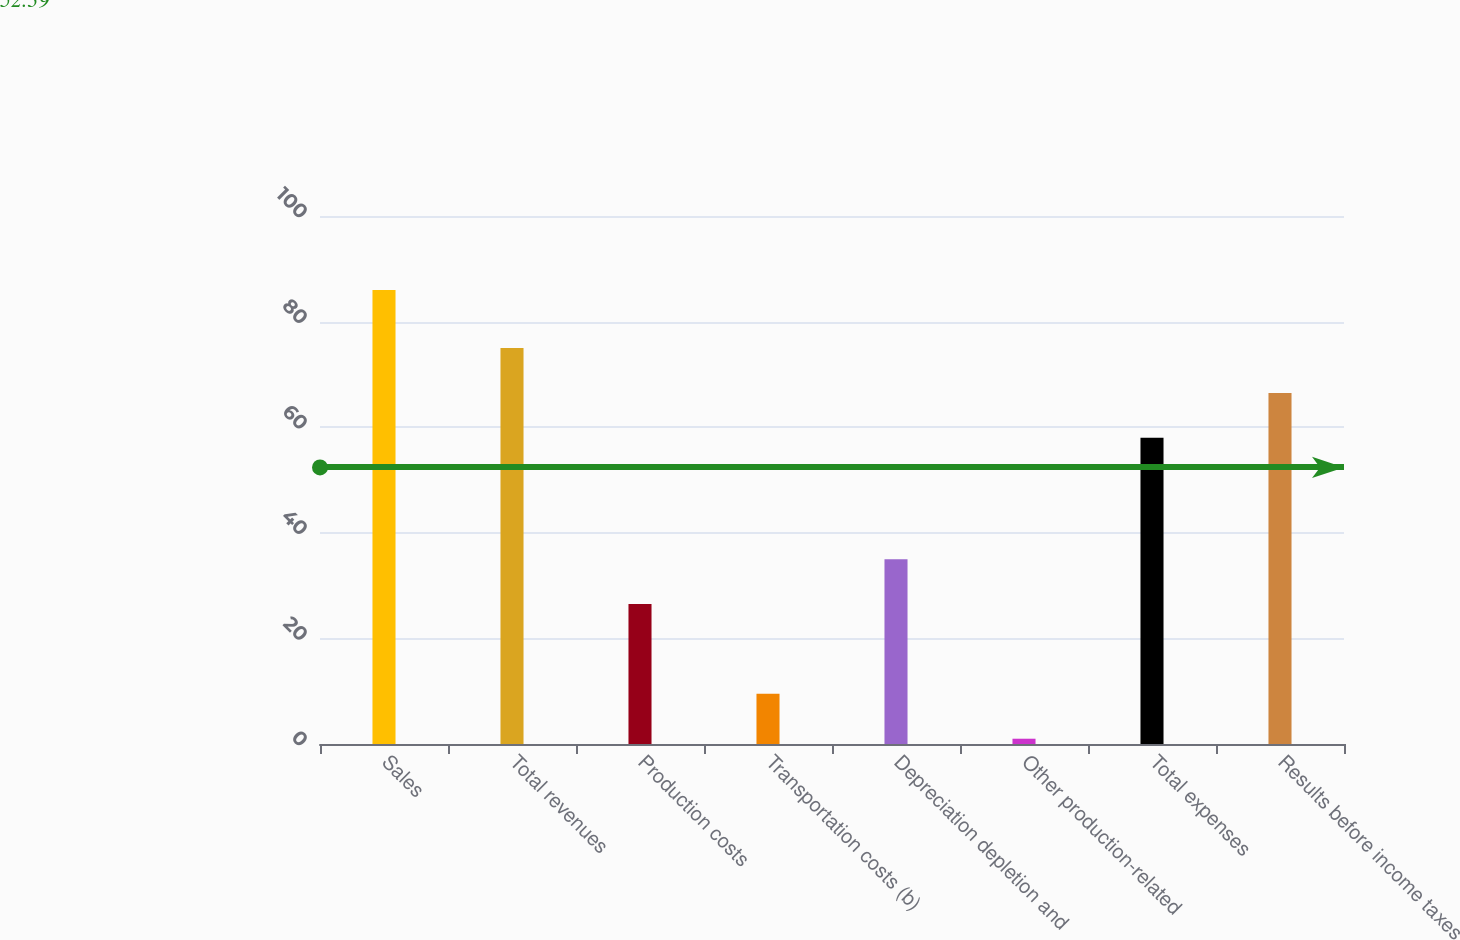Convert chart to OTSL. <chart><loc_0><loc_0><loc_500><loc_500><bar_chart><fcel>Sales<fcel>Total revenues<fcel>Production costs<fcel>Transportation costs (b)<fcel>Depreciation depletion and<fcel>Other production-related<fcel>Total expenses<fcel>Results before income taxes<nl><fcel>86<fcel>75<fcel>26.5<fcel>9.5<fcel>35<fcel>1<fcel>58<fcel>66.5<nl></chart> 